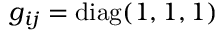Convert formula to latex. <formula><loc_0><loc_0><loc_500><loc_500>g _ { i j } = d i a g ( 1 , 1 , 1 )</formula> 